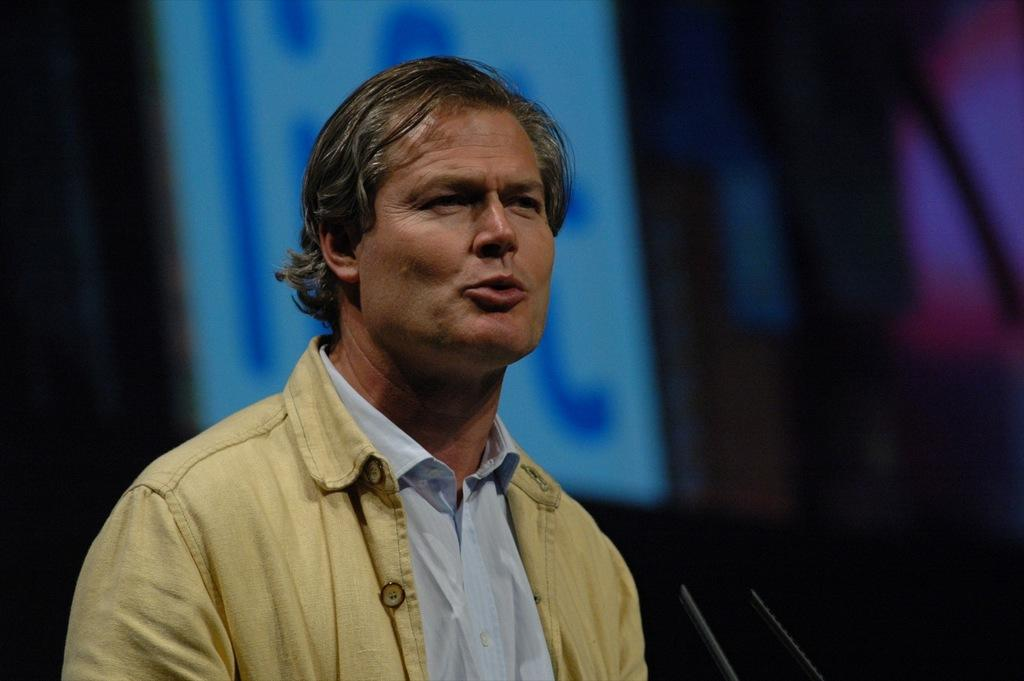What is the main subject of the image? There is a person standing in the image. What objects are in front of the person? There are two mics in front of the person. Can you describe the background of the image? The background of the image is dark. What other object can be seen in the image? There is a screen in the image. How many oranges are on the screen in the image? There are no oranges present in the image, and therefore no such objects can be seen on the screen. 